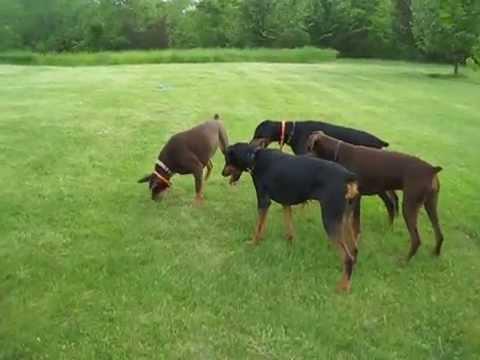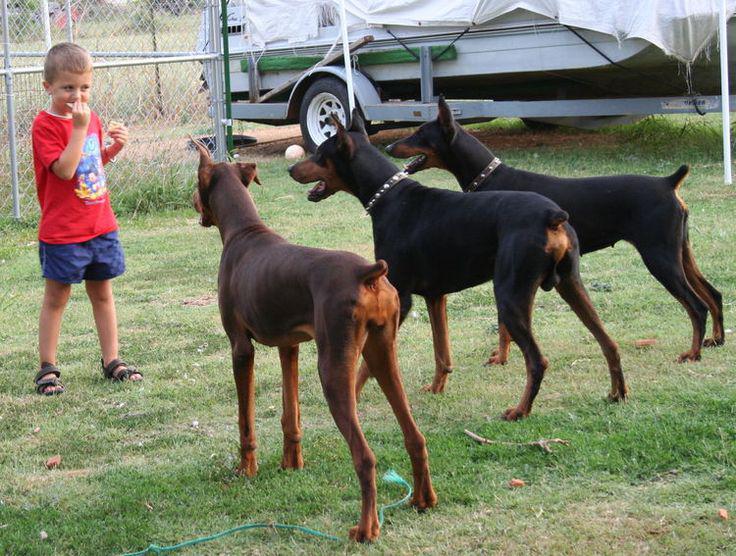The first image is the image on the left, the second image is the image on the right. Given the left and right images, does the statement "One image contains one left-facing doberman with pointy ears and docked tail standing in profile and wearing a vest-type harness." hold true? Answer yes or no. No. The first image is the image on the left, the second image is the image on the right. Given the left and right images, does the statement "A black dog is facing left while wearing a harness." hold true? Answer yes or no. No. 